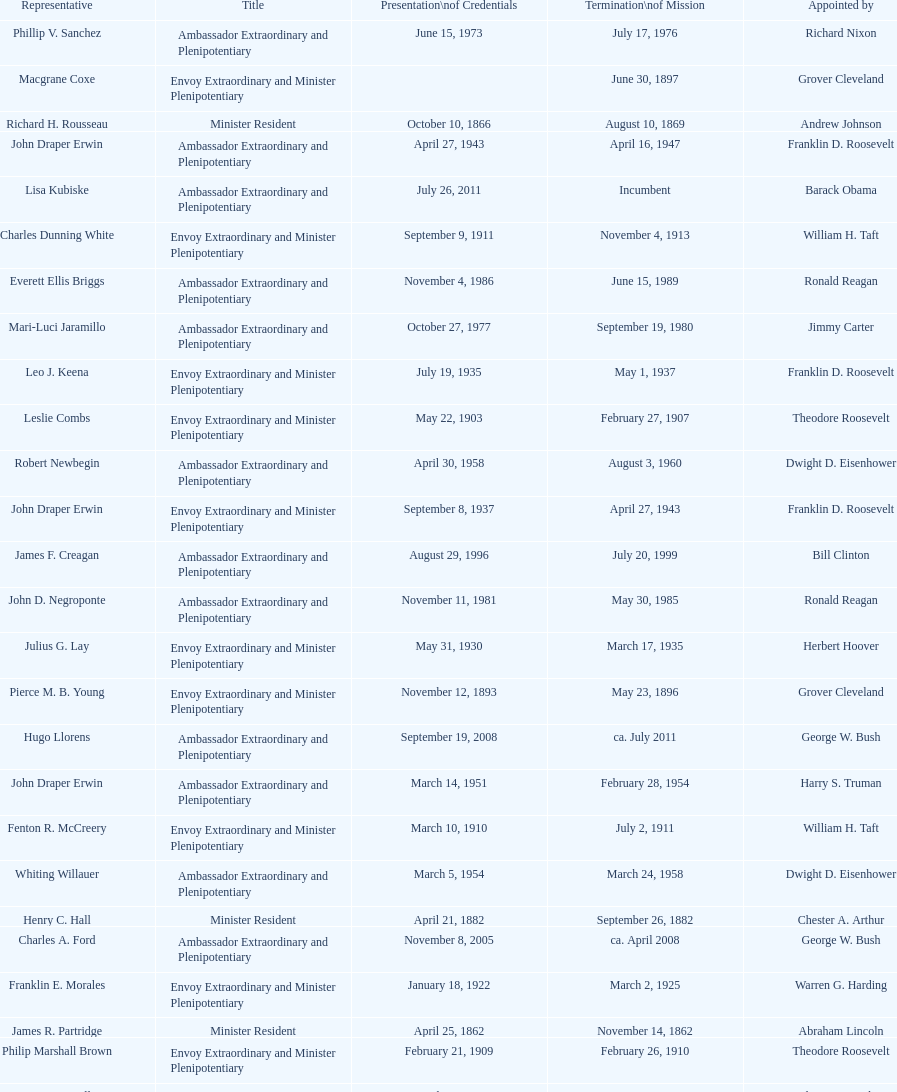How many representatives were appointed by theodore roosevelt? 4. 